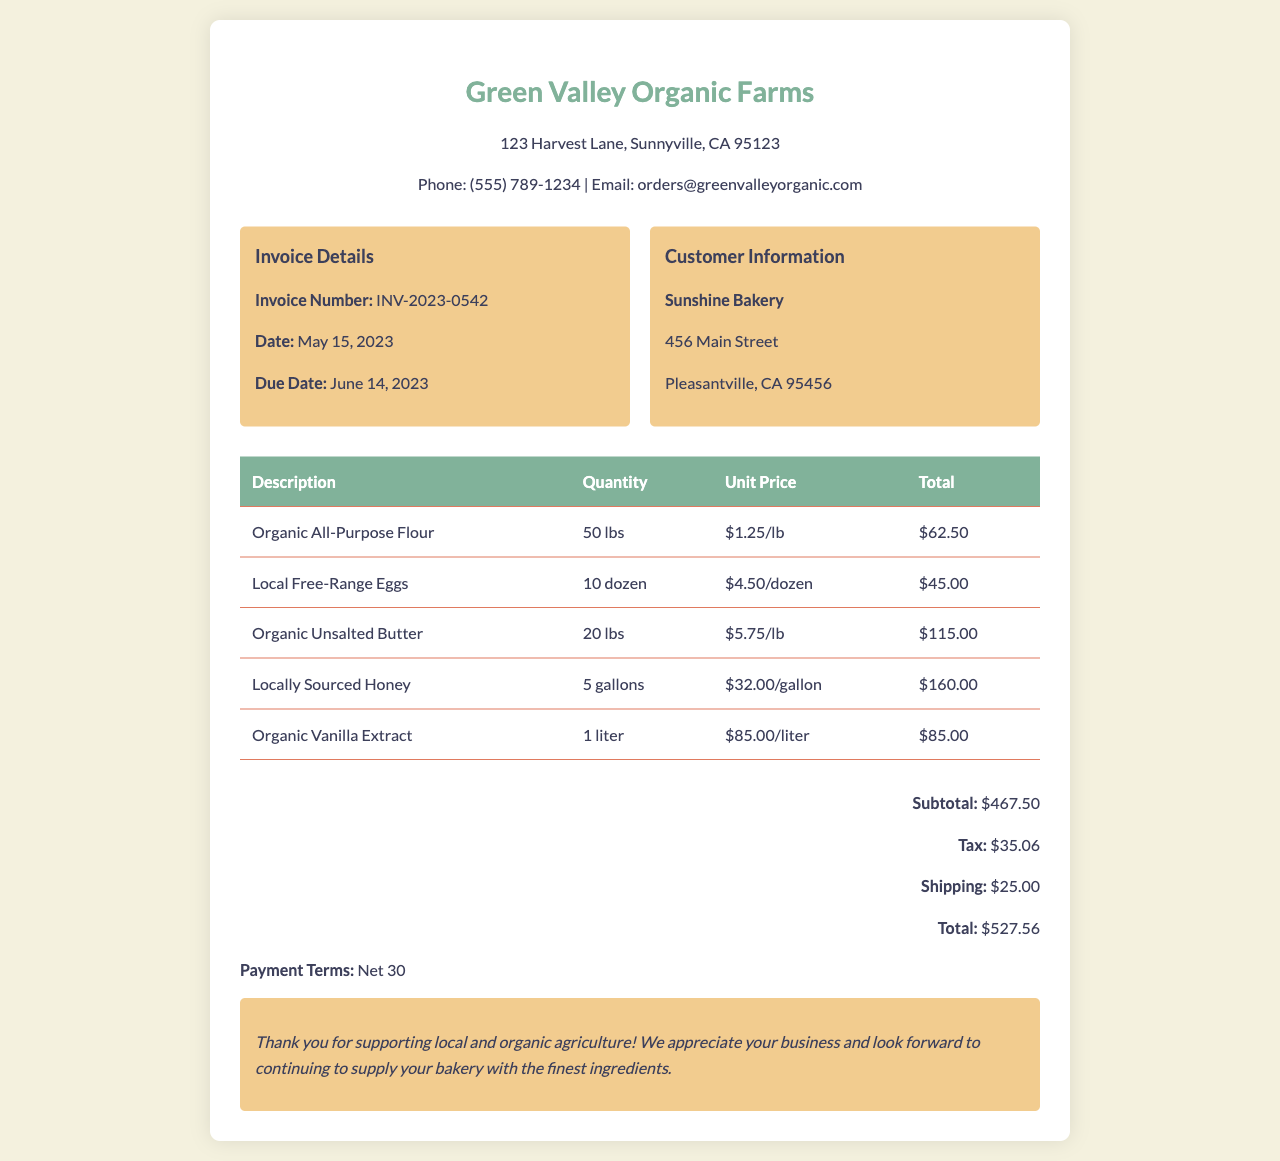What is the invoice number? The invoice number can be found in the invoice details section of the document.
Answer: INV-2023-0542 What is the due date for the invoice? The due date is listed under the invoice details section.
Answer: June 14, 2023 How many lbs of Organic All-Purpose Flour are ordered? The quantity of Organic All-Purpose Flour is mentioned in the invoice table.
Answer: 50 lbs What is the total for Locally Sourced Honey? The total amount for Locally Sourced Honey can be found in the invoice table.
Answer: $160.00 What is the subtotal before tax and shipping? The subtotal is provided in the totals section of the document.
Answer: $467.50 What is the total amount due? The total amount due is listed in the totals section.
Answer: $527.56 What payment terms are specified? The payment terms can be found towards the end of the document.
Answer: Net 30 What is the unit price of Organic Vanilla Extract? The unit price is provided in the invoice table for Organic Vanilla Extract.
Answer: $85.00/liter What is the customer's name? The customer's name is listed in the customer information box.
Answer: Sunshine Bakery 